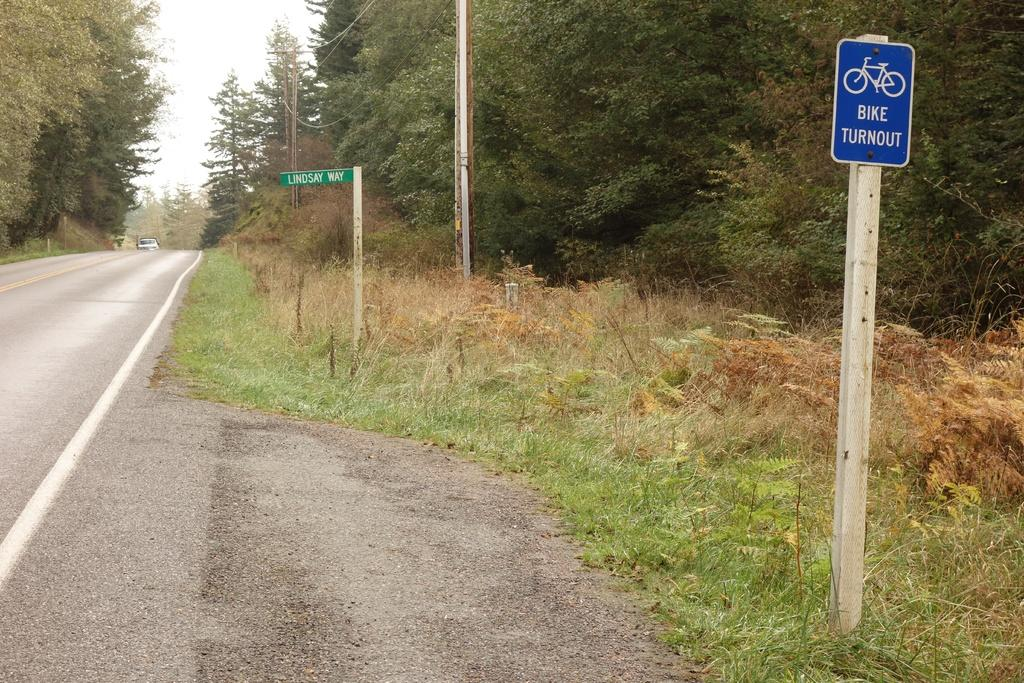<image>
Offer a succinct explanation of the picture presented. on a street called Lindsay Way is a posted sign for bikes 